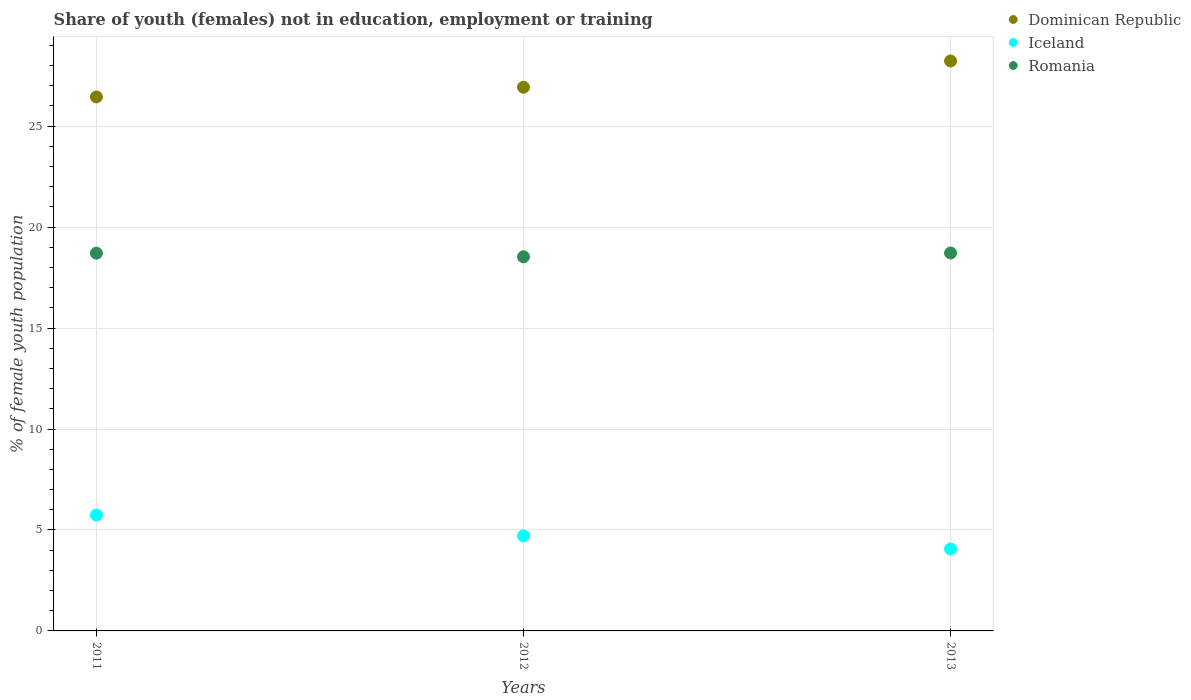How many different coloured dotlines are there?
Offer a very short reply. 3. What is the percentage of unemployed female population in in Iceland in 2012?
Your answer should be very brief. 4.71. Across all years, what is the maximum percentage of unemployed female population in in Dominican Republic?
Your response must be concise. 28.23. Across all years, what is the minimum percentage of unemployed female population in in Romania?
Offer a terse response. 18.53. In which year was the percentage of unemployed female population in in Romania minimum?
Provide a succinct answer. 2012. What is the total percentage of unemployed female population in in Iceland in the graph?
Ensure brevity in your answer.  14.51. What is the difference between the percentage of unemployed female population in in Dominican Republic in 2011 and that in 2012?
Your answer should be very brief. -0.48. What is the difference between the percentage of unemployed female population in in Romania in 2011 and the percentage of unemployed female population in in Iceland in 2012?
Keep it short and to the point. 14. What is the average percentage of unemployed female population in in Iceland per year?
Make the answer very short. 4.84. In the year 2012, what is the difference between the percentage of unemployed female population in in Romania and percentage of unemployed female population in in Iceland?
Give a very brief answer. 13.82. In how many years, is the percentage of unemployed female population in in Romania greater than 9 %?
Make the answer very short. 3. What is the ratio of the percentage of unemployed female population in in Iceland in 2012 to that in 2013?
Your answer should be compact. 1.16. Is the difference between the percentage of unemployed female population in in Romania in 2012 and 2013 greater than the difference between the percentage of unemployed female population in in Iceland in 2012 and 2013?
Offer a terse response. No. What is the difference between the highest and the second highest percentage of unemployed female population in in Dominican Republic?
Provide a succinct answer. 1.3. What is the difference between the highest and the lowest percentage of unemployed female population in in Dominican Republic?
Your response must be concise. 1.78. In how many years, is the percentage of unemployed female population in in Iceland greater than the average percentage of unemployed female population in in Iceland taken over all years?
Provide a succinct answer. 1. Is the sum of the percentage of unemployed female population in in Romania in 2011 and 2013 greater than the maximum percentage of unemployed female population in in Iceland across all years?
Keep it short and to the point. Yes. Does the percentage of unemployed female population in in Iceland monotonically increase over the years?
Your answer should be compact. No. Is the percentage of unemployed female population in in Iceland strictly greater than the percentage of unemployed female population in in Dominican Republic over the years?
Give a very brief answer. No. How many years are there in the graph?
Your answer should be very brief. 3. Are the values on the major ticks of Y-axis written in scientific E-notation?
Your answer should be compact. No. Does the graph contain any zero values?
Ensure brevity in your answer.  No. How many legend labels are there?
Provide a short and direct response. 3. How are the legend labels stacked?
Keep it short and to the point. Vertical. What is the title of the graph?
Your answer should be very brief. Share of youth (females) not in education, employment or training. What is the label or title of the Y-axis?
Make the answer very short. % of female youth population. What is the % of female youth population of Dominican Republic in 2011?
Your answer should be compact. 26.45. What is the % of female youth population in Iceland in 2011?
Give a very brief answer. 5.74. What is the % of female youth population in Romania in 2011?
Give a very brief answer. 18.71. What is the % of female youth population of Dominican Republic in 2012?
Provide a succinct answer. 26.93. What is the % of female youth population in Iceland in 2012?
Your answer should be very brief. 4.71. What is the % of female youth population in Romania in 2012?
Make the answer very short. 18.53. What is the % of female youth population in Dominican Republic in 2013?
Make the answer very short. 28.23. What is the % of female youth population in Iceland in 2013?
Offer a very short reply. 4.06. What is the % of female youth population in Romania in 2013?
Give a very brief answer. 18.72. Across all years, what is the maximum % of female youth population of Dominican Republic?
Provide a short and direct response. 28.23. Across all years, what is the maximum % of female youth population in Iceland?
Offer a very short reply. 5.74. Across all years, what is the maximum % of female youth population in Romania?
Give a very brief answer. 18.72. Across all years, what is the minimum % of female youth population of Dominican Republic?
Your response must be concise. 26.45. Across all years, what is the minimum % of female youth population in Iceland?
Your answer should be compact. 4.06. Across all years, what is the minimum % of female youth population in Romania?
Your answer should be very brief. 18.53. What is the total % of female youth population of Dominican Republic in the graph?
Provide a succinct answer. 81.61. What is the total % of female youth population of Iceland in the graph?
Make the answer very short. 14.51. What is the total % of female youth population of Romania in the graph?
Offer a terse response. 55.96. What is the difference between the % of female youth population in Dominican Republic in 2011 and that in 2012?
Offer a terse response. -0.48. What is the difference between the % of female youth population of Romania in 2011 and that in 2012?
Offer a terse response. 0.18. What is the difference between the % of female youth population of Dominican Republic in 2011 and that in 2013?
Provide a succinct answer. -1.78. What is the difference between the % of female youth population in Iceland in 2011 and that in 2013?
Your answer should be very brief. 1.68. What is the difference between the % of female youth population in Romania in 2011 and that in 2013?
Offer a terse response. -0.01. What is the difference between the % of female youth population in Iceland in 2012 and that in 2013?
Make the answer very short. 0.65. What is the difference between the % of female youth population of Romania in 2012 and that in 2013?
Give a very brief answer. -0.19. What is the difference between the % of female youth population of Dominican Republic in 2011 and the % of female youth population of Iceland in 2012?
Offer a very short reply. 21.74. What is the difference between the % of female youth population of Dominican Republic in 2011 and the % of female youth population of Romania in 2012?
Give a very brief answer. 7.92. What is the difference between the % of female youth population of Iceland in 2011 and the % of female youth population of Romania in 2012?
Keep it short and to the point. -12.79. What is the difference between the % of female youth population of Dominican Republic in 2011 and the % of female youth population of Iceland in 2013?
Provide a short and direct response. 22.39. What is the difference between the % of female youth population in Dominican Republic in 2011 and the % of female youth population in Romania in 2013?
Your answer should be compact. 7.73. What is the difference between the % of female youth population in Iceland in 2011 and the % of female youth population in Romania in 2013?
Your response must be concise. -12.98. What is the difference between the % of female youth population in Dominican Republic in 2012 and the % of female youth population in Iceland in 2013?
Keep it short and to the point. 22.87. What is the difference between the % of female youth population of Dominican Republic in 2012 and the % of female youth population of Romania in 2013?
Provide a succinct answer. 8.21. What is the difference between the % of female youth population in Iceland in 2012 and the % of female youth population in Romania in 2013?
Keep it short and to the point. -14.01. What is the average % of female youth population in Dominican Republic per year?
Your response must be concise. 27.2. What is the average % of female youth population of Iceland per year?
Your answer should be compact. 4.84. What is the average % of female youth population in Romania per year?
Provide a succinct answer. 18.65. In the year 2011, what is the difference between the % of female youth population of Dominican Republic and % of female youth population of Iceland?
Your answer should be very brief. 20.71. In the year 2011, what is the difference between the % of female youth population in Dominican Republic and % of female youth population in Romania?
Your answer should be compact. 7.74. In the year 2011, what is the difference between the % of female youth population in Iceland and % of female youth population in Romania?
Offer a very short reply. -12.97. In the year 2012, what is the difference between the % of female youth population in Dominican Republic and % of female youth population in Iceland?
Make the answer very short. 22.22. In the year 2012, what is the difference between the % of female youth population in Iceland and % of female youth population in Romania?
Keep it short and to the point. -13.82. In the year 2013, what is the difference between the % of female youth population in Dominican Republic and % of female youth population in Iceland?
Your answer should be compact. 24.17. In the year 2013, what is the difference between the % of female youth population of Dominican Republic and % of female youth population of Romania?
Your answer should be very brief. 9.51. In the year 2013, what is the difference between the % of female youth population in Iceland and % of female youth population in Romania?
Make the answer very short. -14.66. What is the ratio of the % of female youth population of Dominican Republic in 2011 to that in 2012?
Give a very brief answer. 0.98. What is the ratio of the % of female youth population of Iceland in 2011 to that in 2012?
Your response must be concise. 1.22. What is the ratio of the % of female youth population in Romania in 2011 to that in 2012?
Provide a short and direct response. 1.01. What is the ratio of the % of female youth population in Dominican Republic in 2011 to that in 2013?
Your answer should be very brief. 0.94. What is the ratio of the % of female youth population of Iceland in 2011 to that in 2013?
Your response must be concise. 1.41. What is the ratio of the % of female youth population of Romania in 2011 to that in 2013?
Your answer should be compact. 1. What is the ratio of the % of female youth population of Dominican Republic in 2012 to that in 2013?
Provide a succinct answer. 0.95. What is the ratio of the % of female youth population in Iceland in 2012 to that in 2013?
Your answer should be very brief. 1.16. What is the ratio of the % of female youth population in Romania in 2012 to that in 2013?
Provide a short and direct response. 0.99. What is the difference between the highest and the second highest % of female youth population of Iceland?
Provide a short and direct response. 1.03. What is the difference between the highest and the second highest % of female youth population of Romania?
Offer a very short reply. 0.01. What is the difference between the highest and the lowest % of female youth population of Dominican Republic?
Your answer should be compact. 1.78. What is the difference between the highest and the lowest % of female youth population in Iceland?
Give a very brief answer. 1.68. What is the difference between the highest and the lowest % of female youth population in Romania?
Offer a terse response. 0.19. 